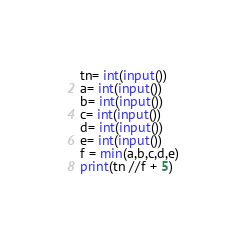<code> <loc_0><loc_0><loc_500><loc_500><_Python_>tn= int(input())
a= int(input())
b= int(input())
c= int(input())
d= int(input())
e= int(input())
f = min(a,b,c,d,e)
print(tn //f + 5)</code> 